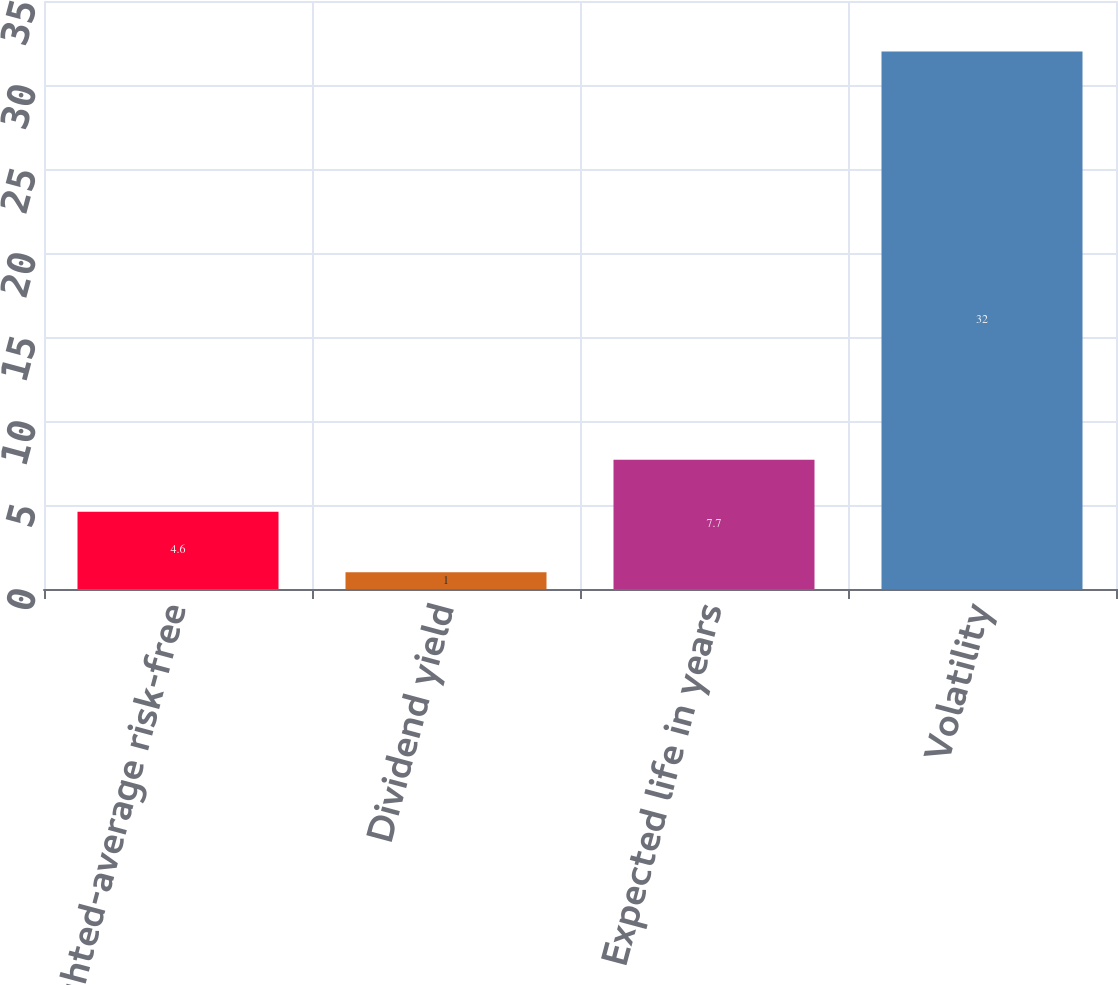Convert chart to OTSL. <chart><loc_0><loc_0><loc_500><loc_500><bar_chart><fcel>Weighted-average risk-free<fcel>Dividend yield<fcel>Expected life in years<fcel>Volatility<nl><fcel>4.6<fcel>1<fcel>7.7<fcel>32<nl></chart> 